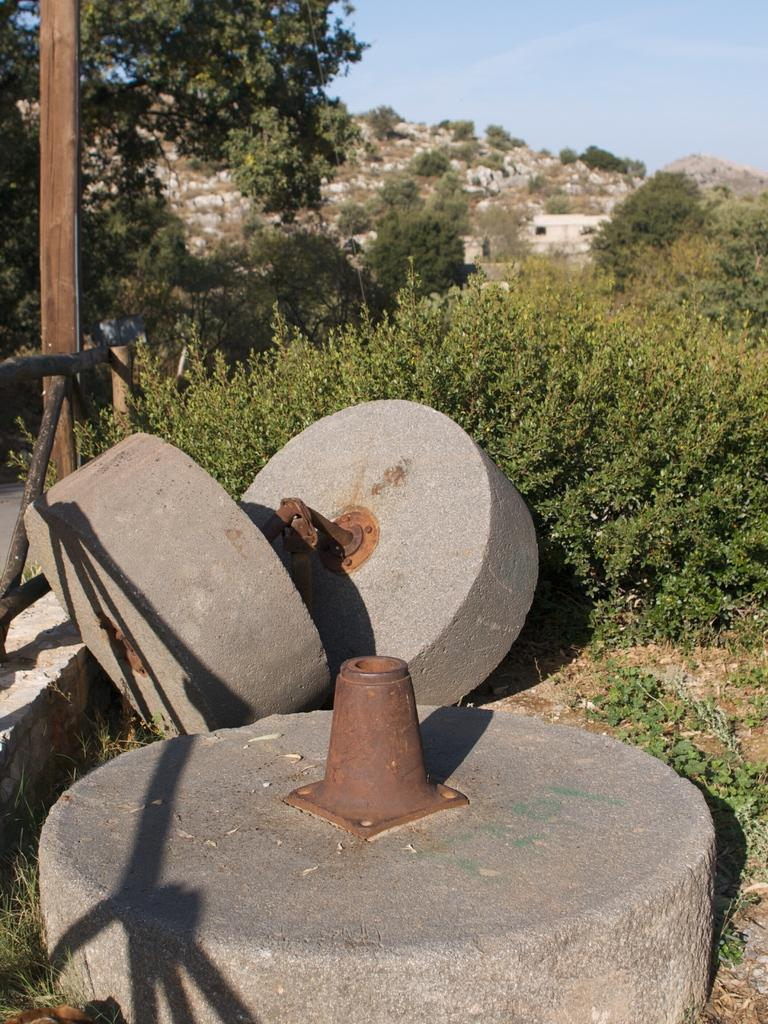What type of machinery is present in the image? There are concrete rollers in the image. What type of vegetation can be seen on the right side of the image? There are bushes and trees on the right side of the image. Where is the father's office located in the image? There is no father or office present in the image. What type of furniture can be seen in the bedroom in the image? There is no bedroom present in the image. 